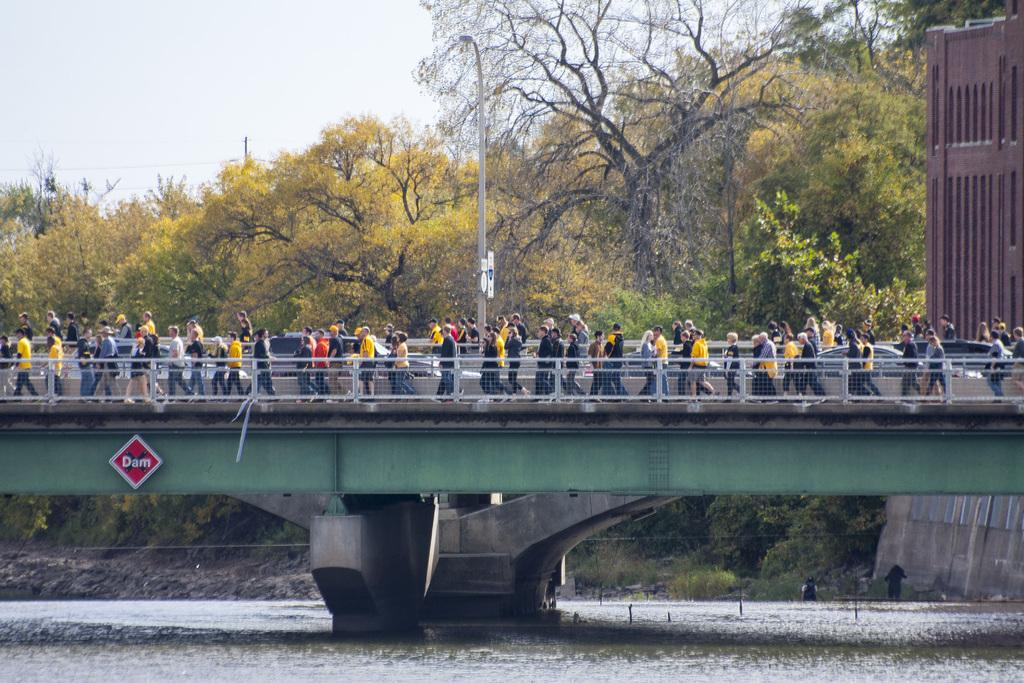What can be seen in the image? There are people and motor vehicles in the image. Where are the people and vehicles located? They are on a bridge. What is the bridge crossing in the image? The bridge is over a river. What can be seen in the background of the image? There are trees and the sky visible in the background. What type of liquid can be seen flowing under the bridge in the image? There is no liquid visible in the image; it only shows a bridge over a river. What material is the gate made of that is blocking the entrance to the bridge in the image? There is no gate blocking the entrance to the bridge in the image. 